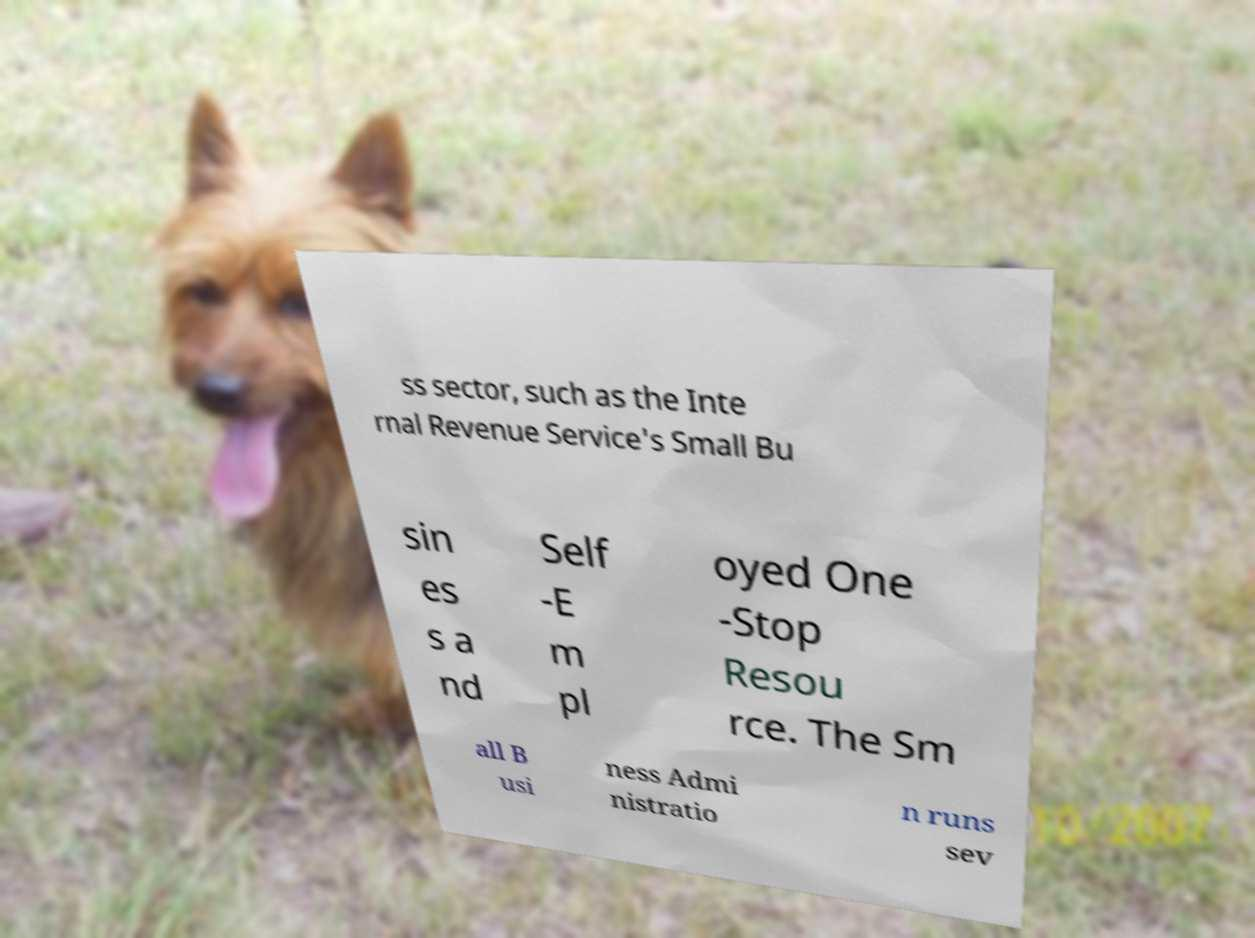Could you assist in decoding the text presented in this image and type it out clearly? ss sector, such as the Inte rnal Revenue Service's Small Bu sin es s a nd Self -E m pl oyed One -Stop Resou rce. The Sm all B usi ness Admi nistratio n runs sev 